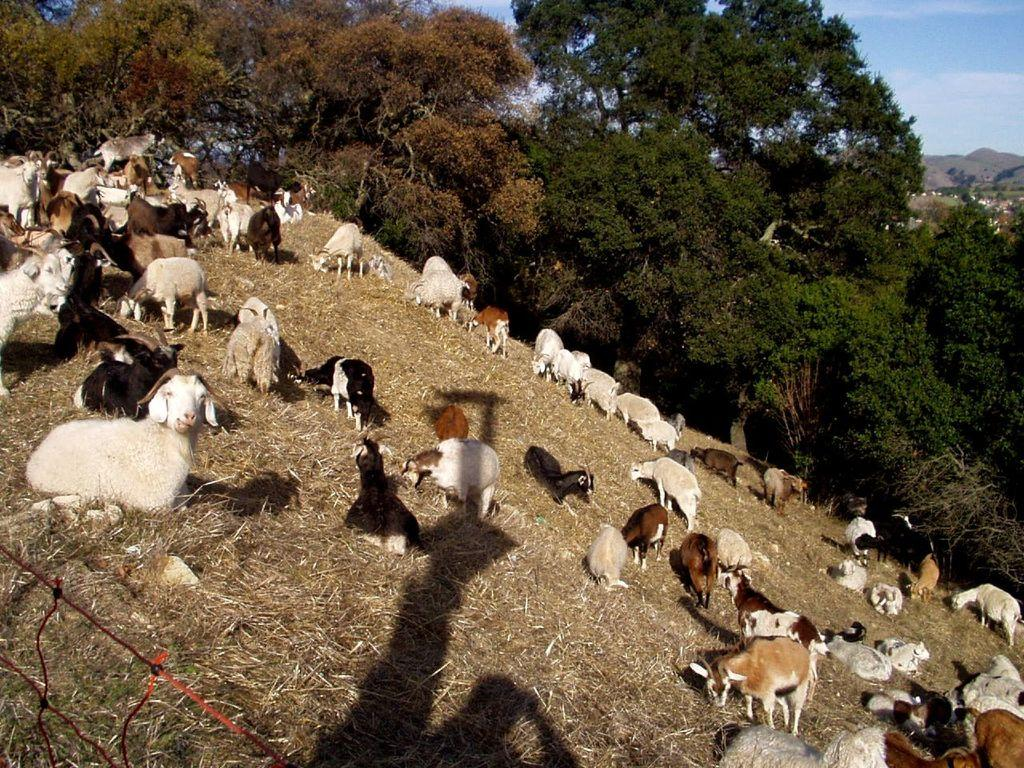What type of vegetation can be seen in the image? There are trees and dried grass in the image. What kind of animals are present in the image? There are animals in the image. What geographical features can be observed in the image? There are hills in the image. What is the weather like in the image? The sky is cloudy in the image. What else can be seen in the image besides the vegetation, animals, and geographical features? There are objects in the image. Can you tell me how many fans are visible in the image? There are no fans present in the image. What type of sheep can be seen grazing on the hills in the image? There are no sheep present in the image; only animals in general are mentioned. 